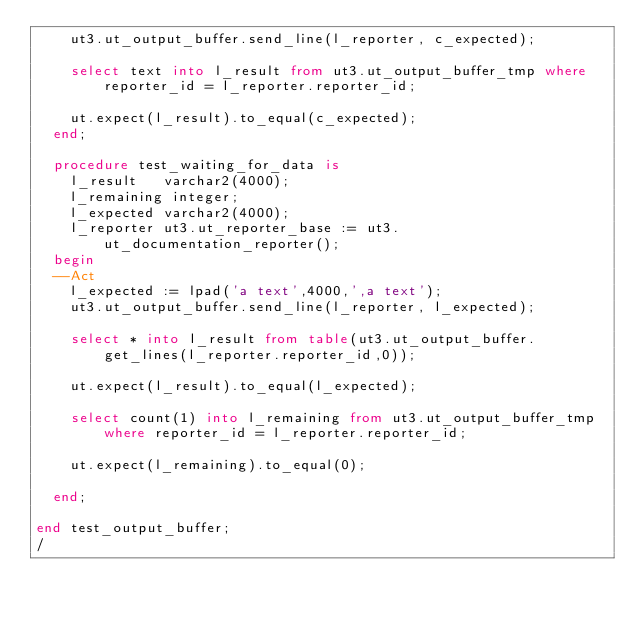Convert code to text. <code><loc_0><loc_0><loc_500><loc_500><_SQL_>    ut3.ut_output_buffer.send_line(l_reporter, c_expected);

    select text into l_result from ut3.ut_output_buffer_tmp where reporter_id = l_reporter.reporter_id;

    ut.expect(l_result).to_equal(c_expected);
  end;
  
  procedure test_waiting_for_data is
    l_result   varchar2(4000);
    l_remaining integer;
    l_expected varchar2(4000);
    l_reporter ut3.ut_reporter_base := ut3.ut_documentation_reporter();
  begin
  --Act
    l_expected := lpad('a text',4000,',a text');
    ut3.ut_output_buffer.send_line(l_reporter, l_expected);

    select * into l_result from table(ut3.ut_output_buffer.get_lines(l_reporter.reporter_id,0));

    ut.expect(l_result).to_equal(l_expected);

    select count(1) into l_remaining from ut3.ut_output_buffer_tmp where reporter_id = l_reporter.reporter_id;

    ut.expect(l_remaining).to_equal(0);
    
  end;
  
end test_output_buffer;
/
</code> 